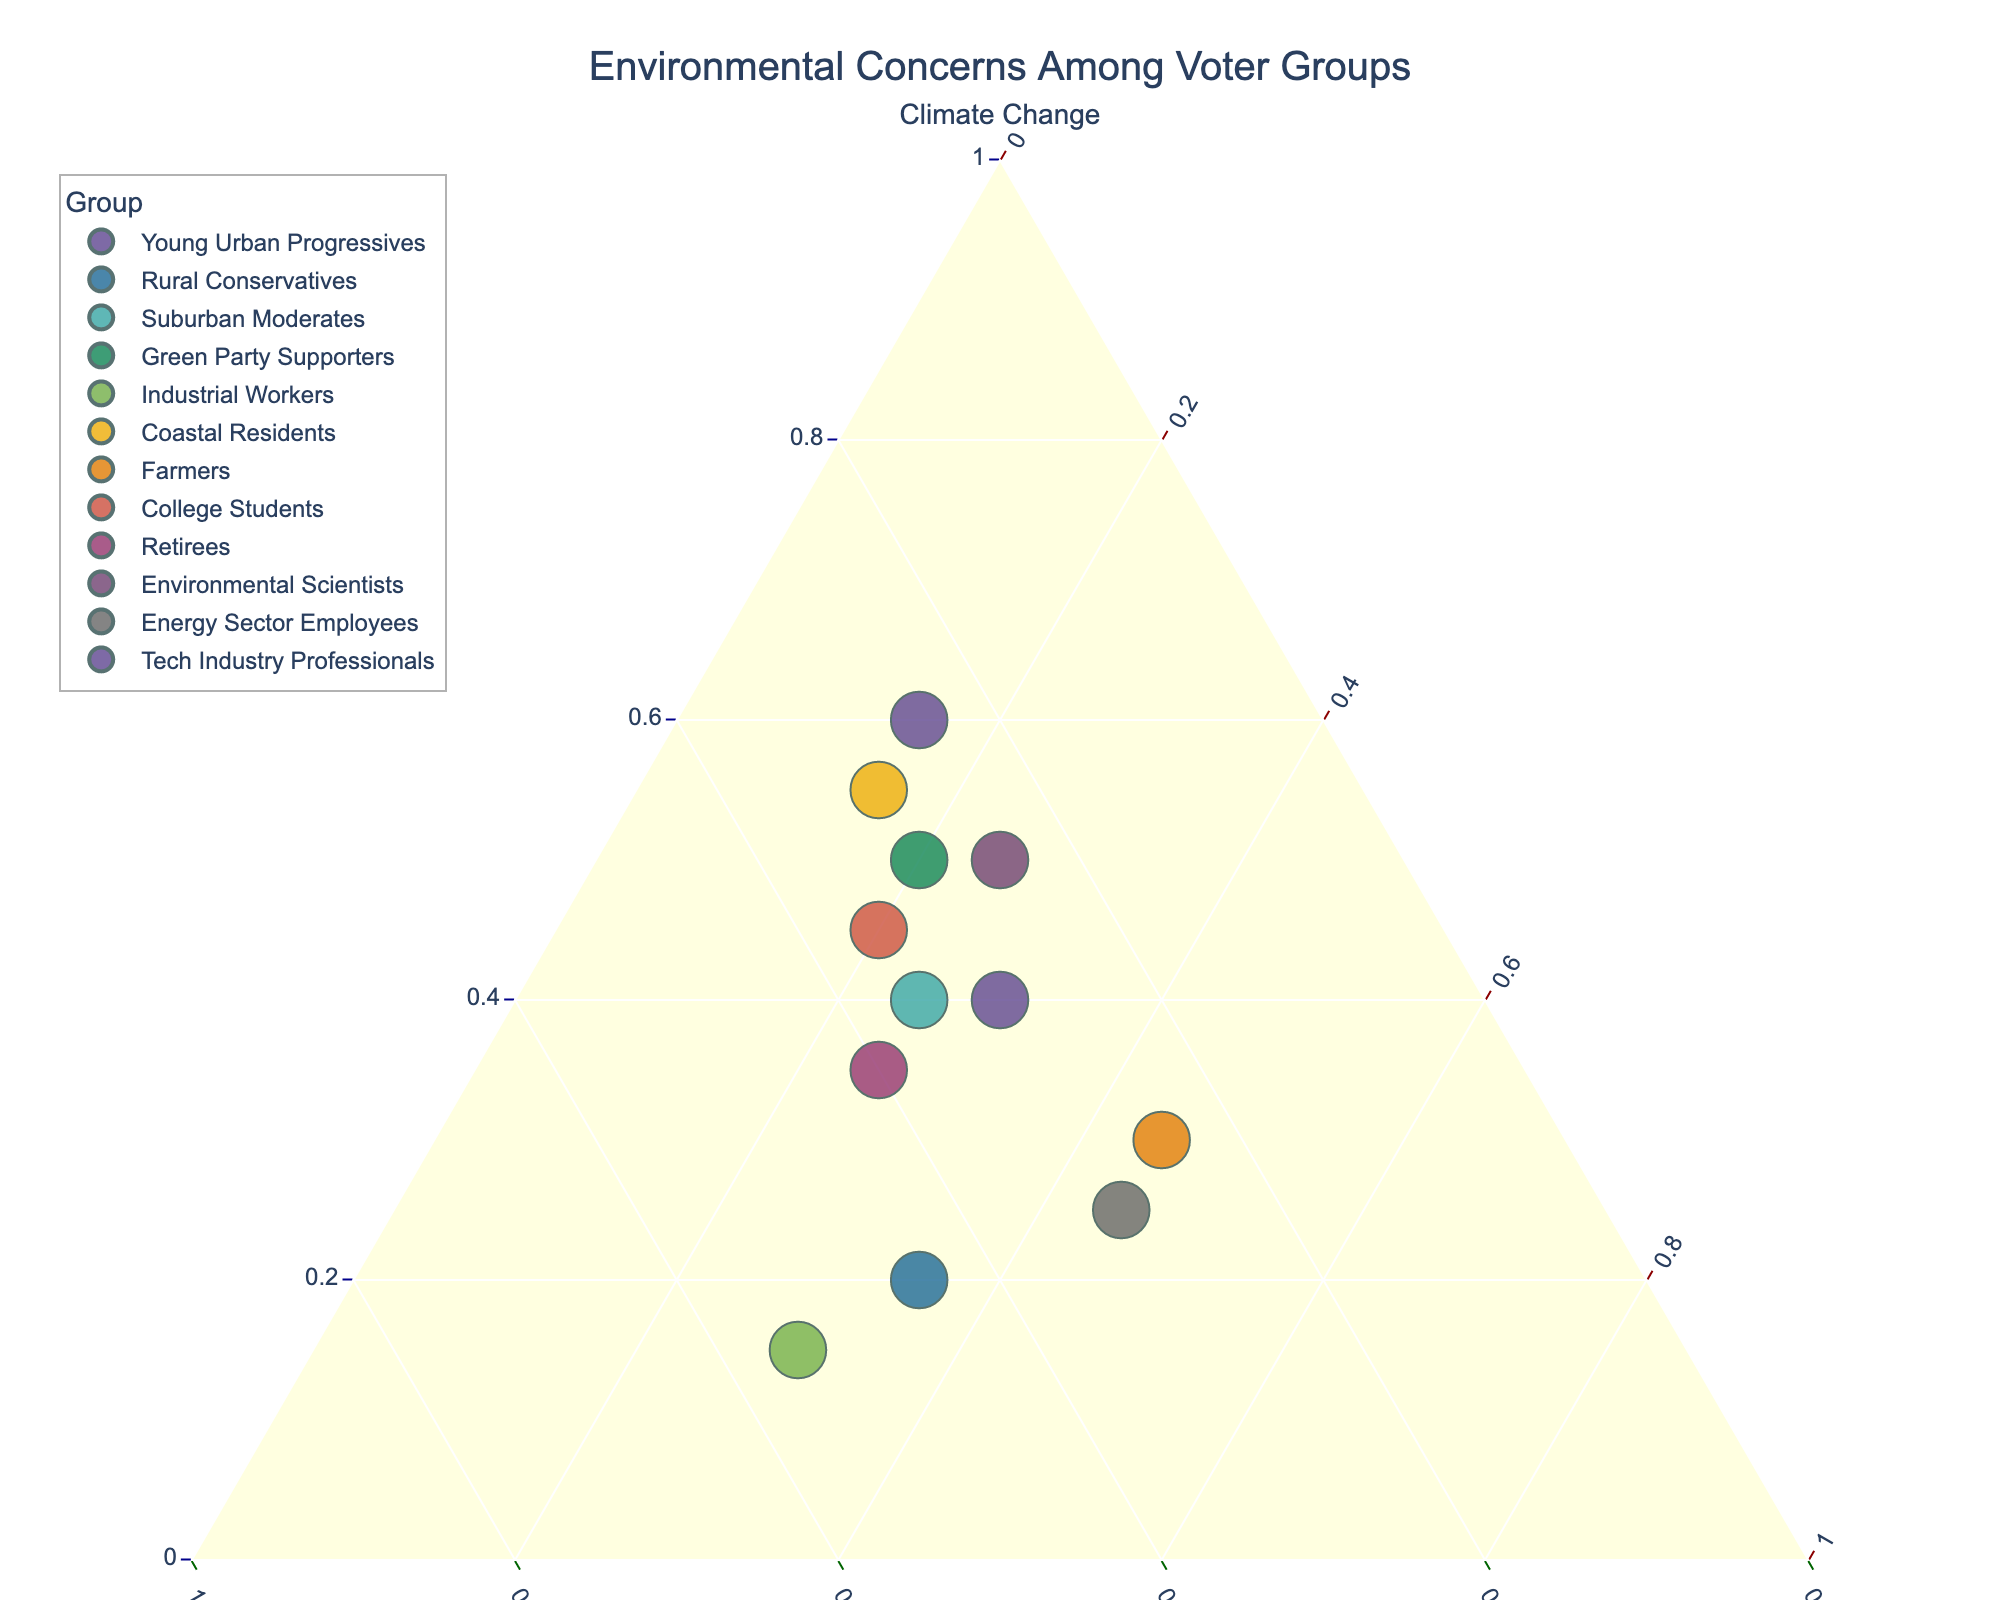What is the title of the ternary plot? The title is usually found at the top of the plot, summarizing the main topic or focus of the data visualized. In this case, the title is "Environmental Concerns Among Voter Groups"
Answer: Environmental Concerns Among Voter Groups Which group has the highest concern for pollution? To find the group with the highest concern for pollution, look at the values on the side labeled "Pollution". The tallest point in this direction represents the group with the highest concern. For pollution, the Industrial Workers group has the highest value at 0.55.
Answer: Industrial Workers Which group has the lowest concern for resource depletion? To identify the group with the lowest concern for resource depletion, refer to the side labeled "Resource Depletion" and find the group at the bottom. Young Urban Progressives has the lowest value at 0.15.
Answer: Young Urban Progressives What are the coordinate points for Suburban Moderates? Locate the Suburban Moderates on the plot and note the values corresponding to Climate Change, Pollution, and Resource Depletion on the ternary plot which are (0.40, 0.35, 0.25).
Answer: (0.40, 0.35, 0.25) Compare the concerns of Energy Sector Employees and Farmers. Which group has a higher concern for climate change? By comparing the position on the "Climate Change" axis, observe that the Energy Sector Employees have a value of 0.25, whereas Farmers have a value of 0.30. Thus, Farmers have a higher concern for climate change.
Answer: Farmers Which group is closest to the midpoint of the ternary plot? The midpoint of the ternary plot represents equal concern for all three issues (around 33.33% for each). Suburban Moderates at (0.40, 0.35, 0.25) and Retirees at (0.35, 0.40, 0.25) appear closest to this midpoint, but a closer examination shows Suburban Moderates slightly nearer to a perfect balance.
Answer: Suburban Moderates Which group shows an equal level of concern for pollution and climate change? Find the groups where the values for climate change and pollution are equal or nearly equal. Environmental Scientists show equal concern for climate change and pollution at 0.50 and 0.25 respectively.
Answer: Environmental Scientists Calculate the average concern for resource depletion among Green Party Supporters, Coastal Residents, and College Students. Sum the concern values for resource depletion for these groups and divide by the number of groups: (0.20 + 0.15 + 0.20) / 3 = 0.1833.
Answer: 0.1833 Which groups align most closely with environmental scientists in their concern distribution? Compare the coordinates of environmental scientists (0.50, 0.25, 0.25) with other groups. Green Party Supporters (0.50, 0.30, 0.20) and Suburban Moderates (0.40, 0.35, 0.25) are quite close.
Answer: Green Party Supporters, Suburban Moderates What is the range of values for resource depletion across all groups? To determine the range, identify the highest and lowest values for resource depletion among the groups. The highest value is 0.45 (Farmers and Energy Sector Employees) and the lowest is 0.15 (Young Urban Progressives and Coastal Residents), so the range is 0.45 - 0.15 = 0.30.
Answer: 0.30 